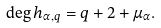Convert formula to latex. <formula><loc_0><loc_0><loc_500><loc_500>\deg h _ { \alpha , q } = q + 2 + \mu _ { \alpha } .</formula> 